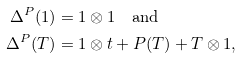Convert formula to latex. <formula><loc_0><loc_0><loc_500><loc_500>\Delta ^ { P } ( 1 ) & = 1 \otimes 1 \quad \text {and} \\ \Delta ^ { P } ( T ) & = 1 \otimes t + P ( T ) + T \otimes 1 ,</formula> 